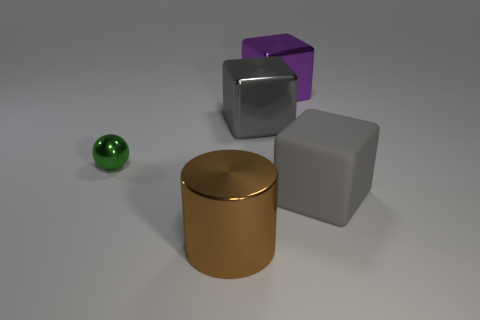Subtract all purple blocks. How many blocks are left? 2 Subtract all big gray matte cubes. How many cubes are left? 2 Subtract all red balls. How many gray cubes are left? 2 Add 5 large cyan matte objects. How many large cyan matte objects exist? 5 Add 2 large green rubber cylinders. How many objects exist? 7 Subtract 0 blue spheres. How many objects are left? 5 Subtract all blocks. How many objects are left? 2 Subtract all green cylinders. Subtract all yellow spheres. How many cylinders are left? 1 Subtract all big purple rubber cubes. Subtract all big gray cubes. How many objects are left? 3 Add 2 purple blocks. How many purple blocks are left? 3 